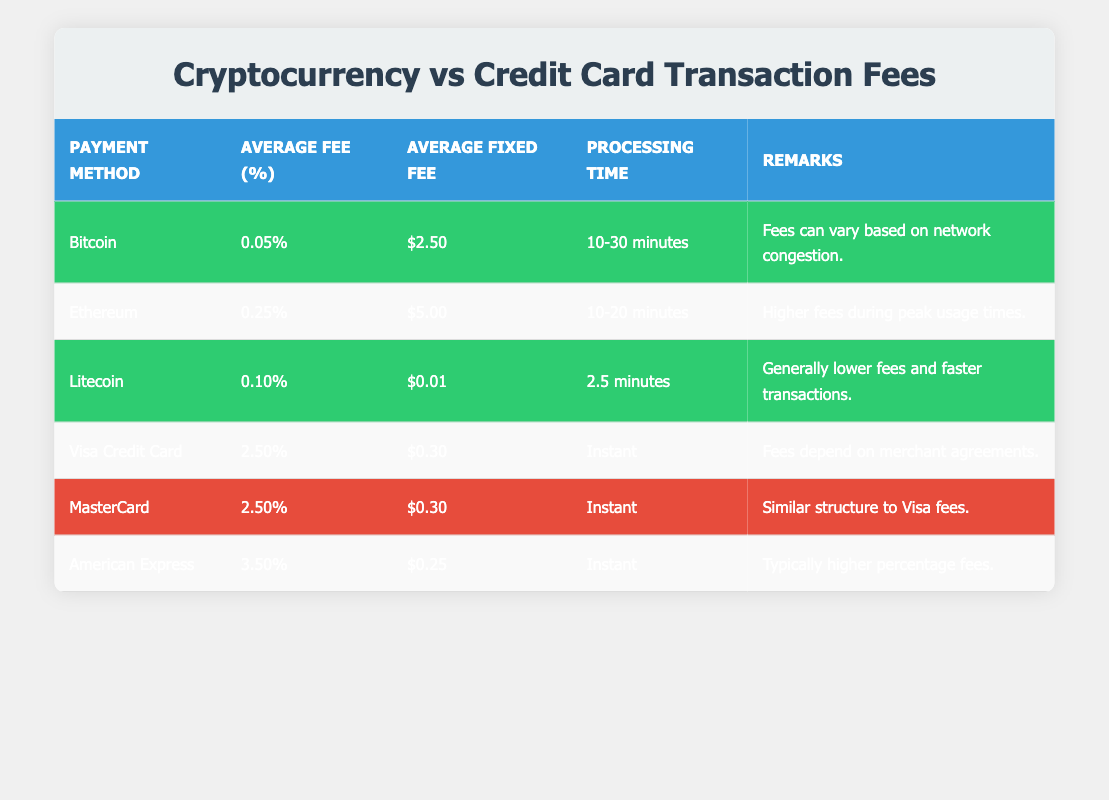What is the average fee percentage for Bitcoin transactions? In the table, under the "Bitcoin" row, the "Average Fee (%)" column shows 0.05. Thus, the average fee percentage for Bitcoin transactions is therefore 0.05%.
Answer: 0.05% Which payment method has the lowest average fixed fee? The table shows the average fixed fees for different payment methods. Comparing values, Litecoin has an average fixed fee of $0.01, which is the lowest among all listed methods.
Answer: $0.01 Is the processing time for Litecoin faster than that of Bitcoin? The processing time for Litecoin is listed as 2.5 minutes, while Bitcoin's processing time is 10-30 minutes. Since 2.5 minutes is less than the minimum of 10 minutes for Bitcoin, this statement is true.
Answer: Yes What is the difference in average fee percentage between Ethereum and American Express? Ethereum has an average fee percentage of 0.25 and American Express has 3.50. To find the difference, subtract Ethereum's fee from American Express's fee: 3.50 - 0.25 = 3.25.
Answer: 3.25% Which payment method(s) take longer than 10 minutes for processing? Upon reviewing the processing times listed, Bitcoin (10-30 minutes) and Ethereum (10-20 minutes) take longer than 10 minutes, while Litecoin is quicker. Therefore, the payments that take longer are Bitcoin and Ethereum.
Answer: Bitcoin, Ethereum What is the average processing time across all payment methods in the table? The processing times listed are 10-30 minutes for Bitcoin, 10-20 minutes for Ethereum, 2.5 minutes for Litecoin, and instant for all credit cards. Converting all to a single measure, we use 20 minutes for Bitcoin and 15 minutes for Ethereum as simple midpoints, then for instant, we consider it as 0 minutes. We average these: (20 + 15 + 2.5 + 0 + 0 + 0)/6 = 3.75 minutes approximately.
Answer: Approximately 3.75 minutes Which payment method has the highest transaction fee percentage? Reviewing the fee percentages, American Express stands out with a fee of 3.50%, which is higher compared to other methods.
Answer: American Express What is the total average fee percentage for credit card payments combined? The average fee percentages for credit cards are Visa and MasterCard both at 2.5%, and American Express at 3.5%. To find the total average, calculate: (2.5 + 2.5 + 3.5) / 3 = 2.83.
Answer: 2.83% Are all cryptocurrency transaction fees less than those of American Express? American Express has a fee percentage of 3.5%. Reviewing the crypto fees—Bitcoin at 0.05%, Ethereum at 0.25%, and Litecoin at 0.10%—all these fees are indeed lower than 3.5%. Thus, this statement is valid.
Answer: Yes 